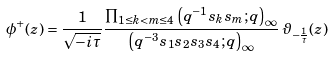<formula> <loc_0><loc_0><loc_500><loc_500>\phi ^ { + } ( z ) = \frac { 1 } { \sqrt { - i \tau } } \frac { \prod _ { 1 \leq k < m \leq 4 } \left ( q ^ { - 1 } s _ { k } s _ { m } ; q \right ) _ { \infty } } { \left ( q ^ { - 3 } s _ { 1 } s _ { 2 } s _ { 3 } s _ { 4 } ; q \right ) _ { \infty } } \, \vartheta _ { - \frac { 1 } { \tau } } ( z )</formula> 